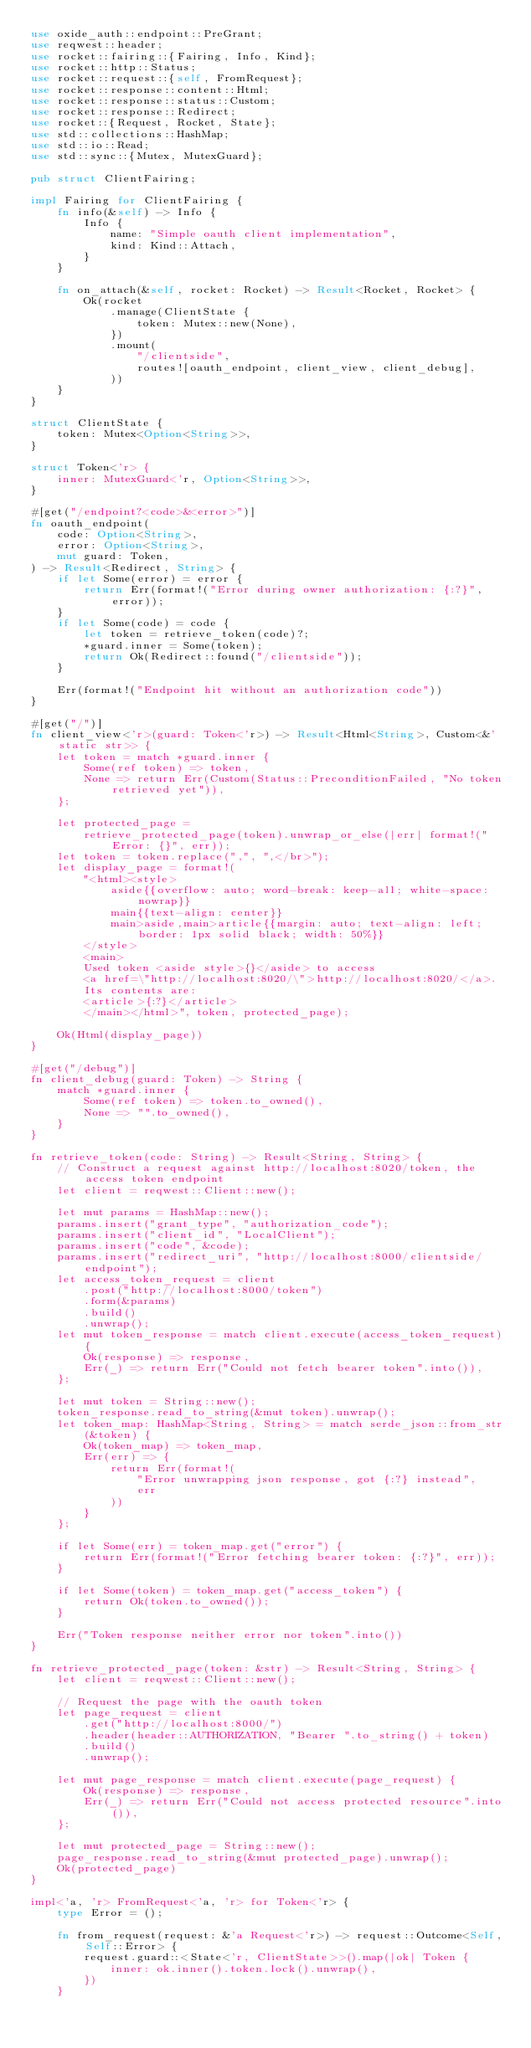Convert code to text. <code><loc_0><loc_0><loc_500><loc_500><_Rust_>use oxide_auth::endpoint::PreGrant;
use reqwest::header;
use rocket::fairing::{Fairing, Info, Kind};
use rocket::http::Status;
use rocket::request::{self, FromRequest};
use rocket::response::content::Html;
use rocket::response::status::Custom;
use rocket::response::Redirect;
use rocket::{Request, Rocket, State};
use std::collections::HashMap;
use std::io::Read;
use std::sync::{Mutex, MutexGuard};

pub struct ClientFairing;

impl Fairing for ClientFairing {
    fn info(&self) -> Info {
        Info {
            name: "Simple oauth client implementation",
            kind: Kind::Attach,
        }
    }

    fn on_attach(&self, rocket: Rocket) -> Result<Rocket, Rocket> {
        Ok(rocket
            .manage(ClientState {
                token: Mutex::new(None),
            })
            .mount(
                "/clientside",
                routes![oauth_endpoint, client_view, client_debug],
            ))
    }
}

struct ClientState {
    token: Mutex<Option<String>>,
}

struct Token<'r> {
    inner: MutexGuard<'r, Option<String>>,
}

#[get("/endpoint?<code>&<error>")]
fn oauth_endpoint(
    code: Option<String>,
    error: Option<String>,
    mut guard: Token,
) -> Result<Redirect, String> {
    if let Some(error) = error {
        return Err(format!("Error during owner authorization: {:?}", error));
    }
    if let Some(code) = code {
        let token = retrieve_token(code)?;
        *guard.inner = Some(token);
        return Ok(Redirect::found("/clientside"));
    }

    Err(format!("Endpoint hit without an authorization code"))
}

#[get("/")]
fn client_view<'r>(guard: Token<'r>) -> Result<Html<String>, Custom<&'static str>> {
    let token = match *guard.inner {
        Some(ref token) => token,
        None => return Err(Custom(Status::PreconditionFailed, "No token retrieved yet")),
    };

    let protected_page =
        retrieve_protected_page(token).unwrap_or_else(|err| format!("Error: {}", err));
    let token = token.replace(",", ",</br>");
    let display_page = format!(
        "<html><style>
            aside{{overflow: auto; word-break: keep-all; white-space: nowrap}}
            main{{text-align: center}}
            main>aside,main>article{{margin: auto; text-align: left; border: 1px solid black; width: 50%}}
        </style>
        <main>
        Used token <aside style>{}</aside> to access
        <a href=\"http://localhost:8020/\">http://localhost:8020/</a>.
        Its contents are:
        <article>{:?}</article>
        </main></html>", token, protected_page);

    Ok(Html(display_page))
}

#[get("/debug")]
fn client_debug(guard: Token) -> String {
    match *guard.inner {
        Some(ref token) => token.to_owned(),
        None => "".to_owned(),
    }
}

fn retrieve_token(code: String) -> Result<String, String> {
    // Construct a request against http://localhost:8020/token, the access token endpoint
    let client = reqwest::Client::new();

    let mut params = HashMap::new();
    params.insert("grant_type", "authorization_code");
    params.insert("client_id", "LocalClient");
    params.insert("code", &code);
    params.insert("redirect_uri", "http://localhost:8000/clientside/endpoint");
    let access_token_request = client
        .post("http://localhost:8000/token")
        .form(&params)
        .build()
        .unwrap();
    let mut token_response = match client.execute(access_token_request) {
        Ok(response) => response,
        Err(_) => return Err("Could not fetch bearer token".into()),
    };

    let mut token = String::new();
    token_response.read_to_string(&mut token).unwrap();
    let token_map: HashMap<String, String> = match serde_json::from_str(&token) {
        Ok(token_map) => token_map,
        Err(err) => {
            return Err(format!(
                "Error unwrapping json response, got {:?} instead",
                err
            ))
        }
    };

    if let Some(err) = token_map.get("error") {
        return Err(format!("Error fetching bearer token: {:?}", err));
    }

    if let Some(token) = token_map.get("access_token") {
        return Ok(token.to_owned());
    }

    Err("Token response neither error nor token".into())
}

fn retrieve_protected_page(token: &str) -> Result<String, String> {
    let client = reqwest::Client::new();

    // Request the page with the oauth token
    let page_request = client
        .get("http://localhost:8000/")
        .header(header::AUTHORIZATION, "Bearer ".to_string() + token)
        .build()
        .unwrap();

    let mut page_response = match client.execute(page_request) {
        Ok(response) => response,
        Err(_) => return Err("Could not access protected resource".into()),
    };

    let mut protected_page = String::new();
    page_response.read_to_string(&mut protected_page).unwrap();
    Ok(protected_page)
}

impl<'a, 'r> FromRequest<'a, 'r> for Token<'r> {
    type Error = ();

    fn from_request(request: &'a Request<'r>) -> request::Outcome<Self, Self::Error> {
        request.guard::<State<'r, ClientState>>().map(|ok| Token {
            inner: ok.inner().token.lock().unwrap(),
        })
    }</code> 